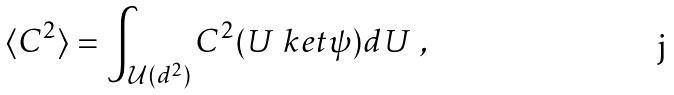<formula> <loc_0><loc_0><loc_500><loc_500>\langle C ^ { 2 } \rangle = \int _ { \mathcal { U } ( d ^ { 2 } ) } C ^ { 2 } ( U \ k e t { \psi } ) d U \ ,</formula> 